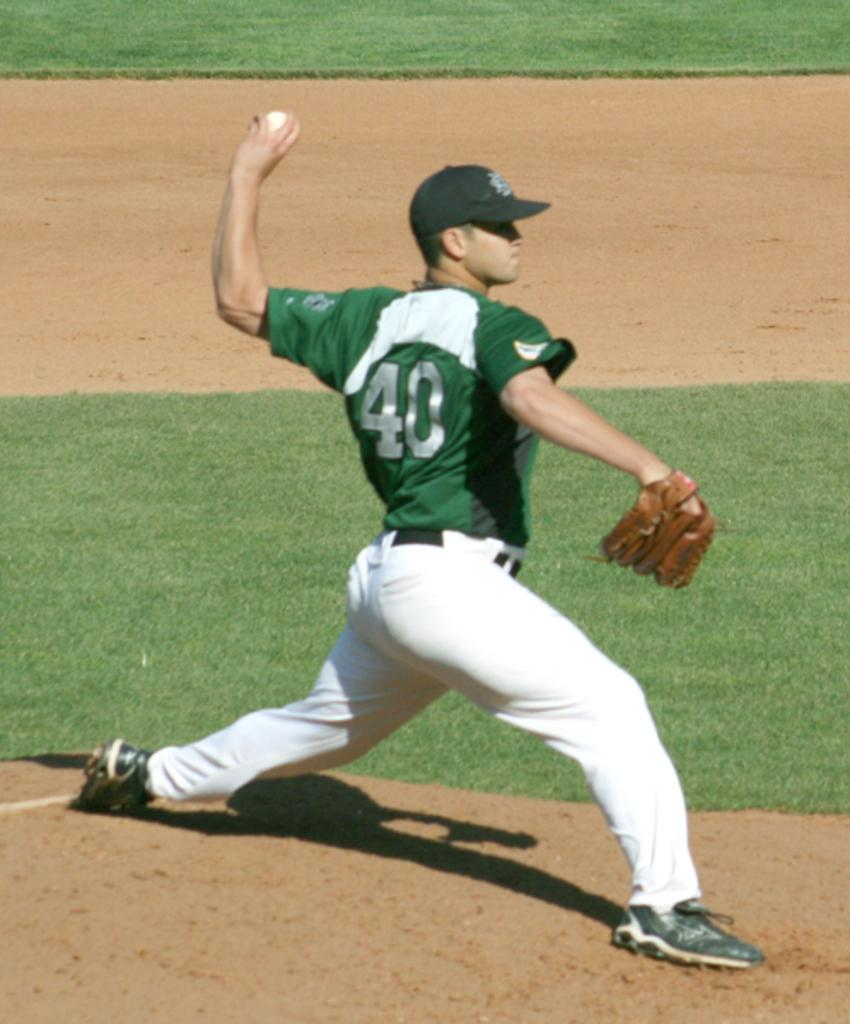<image>
Offer a succinct explanation of the picture presented. Nuber 40 throws out a pitch at a baseball game. 